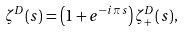<formula> <loc_0><loc_0><loc_500><loc_500>\zeta ^ { D } ( s ) = \left ( 1 + e ^ { - i \, \pi \, s } \right ) \zeta _ { + } ^ { D } ( s ) ,</formula> 